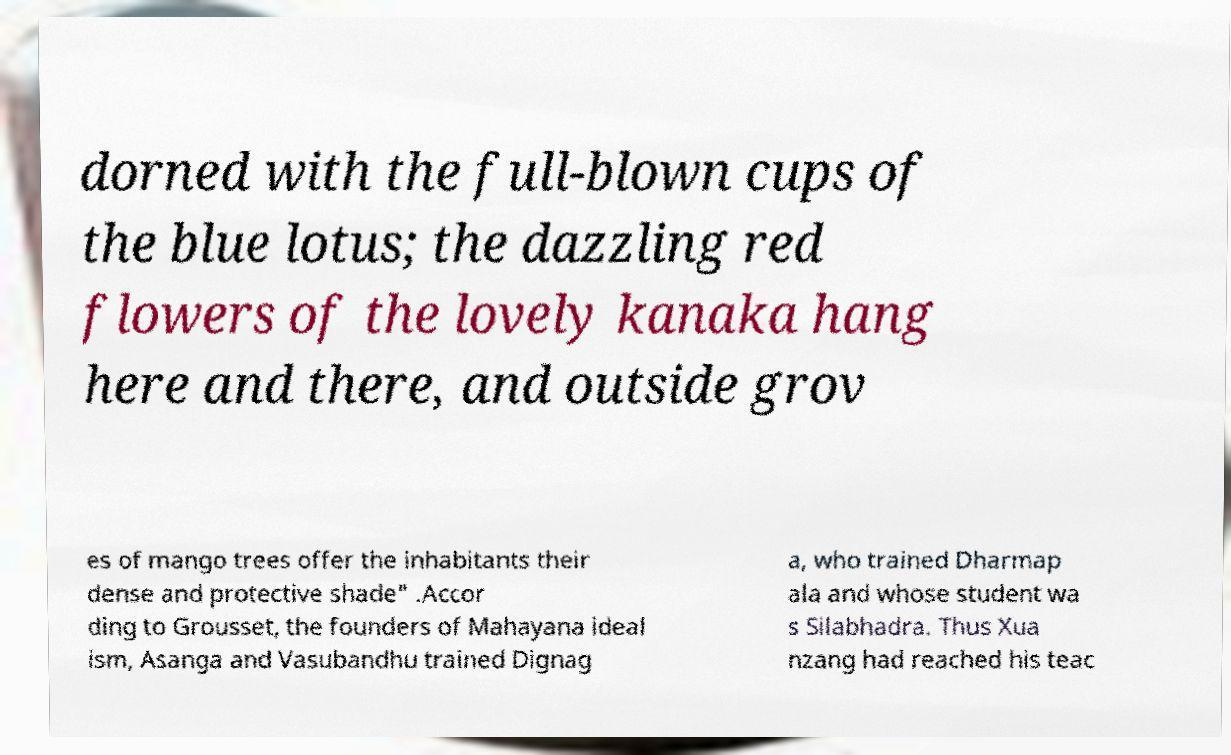For documentation purposes, I need the text within this image transcribed. Could you provide that? dorned with the full-blown cups of the blue lotus; the dazzling red flowers of the lovely kanaka hang here and there, and outside grov es of mango trees offer the inhabitants their dense and protective shade" .Accor ding to Grousset, the founders of Mahayana ideal ism, Asanga and Vasubandhu trained Dignag a, who trained Dharmap ala and whose student wa s Silabhadra. Thus Xua nzang had reached his teac 